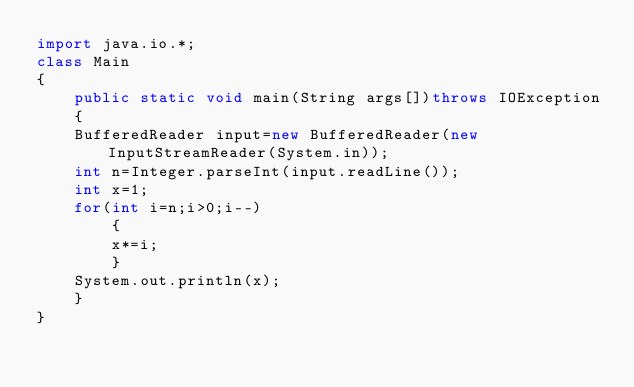Convert code to text. <code><loc_0><loc_0><loc_500><loc_500><_Java_>import java.io.*;
class Main
{
    public static void main(String args[])throws IOException
    {
	BufferedReader input=new BufferedReader(new InputStreamReader(System.in));
	int n=Integer.parseInt(input.readLine());
	int x=1;
	for(int i=n;i>0;i--)
	    {
		x*=i;
	    }
	System.out.println(x);
    }
}</code> 